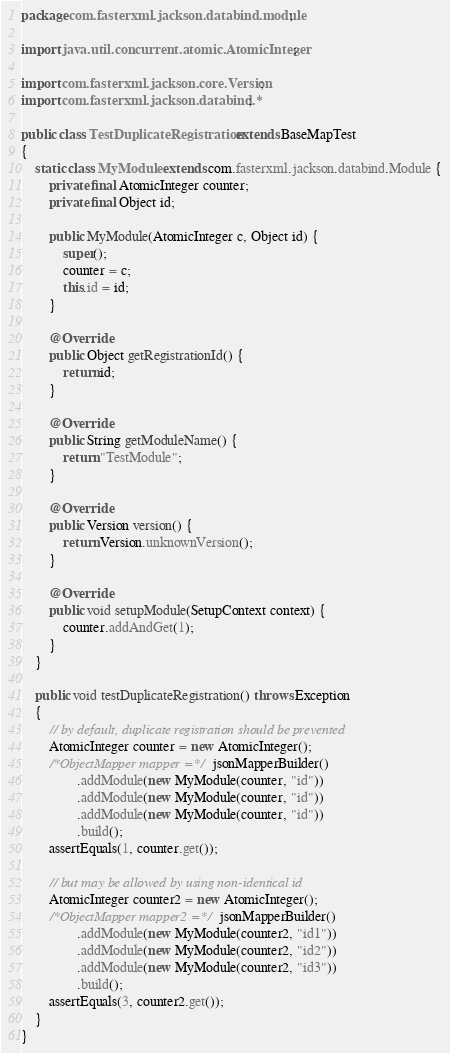Convert code to text. <code><loc_0><loc_0><loc_500><loc_500><_Java_>package com.fasterxml.jackson.databind.module;

import java.util.concurrent.atomic.AtomicInteger;

import com.fasterxml.jackson.core.Version;
import com.fasterxml.jackson.databind.*;

public class TestDuplicateRegistration extends BaseMapTest
{
    static class MyModule extends com.fasterxml.jackson.databind.Module {
        private final AtomicInteger counter;
        private final Object id;

        public MyModule(AtomicInteger c, Object id) {
            super();
            counter = c;
            this.id = id;
        }

        @Override
        public Object getRegistrationId() {
            return id;
        }

        @Override
        public String getModuleName() {
            return "TestModule";
        }

        @Override
        public Version version() {
            return Version.unknownVersion();
        }

        @Override
        public void setupModule(SetupContext context) {
            counter.addAndGet(1);
        }
    }

    public void testDuplicateRegistration() throws Exception
    {
        // by default, duplicate registration should be prevented
        AtomicInteger counter = new AtomicInteger();
        /*ObjectMapper mapper =*/ jsonMapperBuilder()
                .addModule(new MyModule(counter, "id"))
                .addModule(new MyModule(counter, "id"))
                .addModule(new MyModule(counter, "id"))
                .build();
        assertEquals(1, counter.get());

        // but may be allowed by using non-identical id
        AtomicInteger counter2 = new AtomicInteger();
        /*ObjectMapper mapper2 =*/ jsonMapperBuilder()
                .addModule(new MyModule(counter2, "id1"))
                .addModule(new MyModule(counter2, "id2"))
                .addModule(new MyModule(counter2, "id3"))
                .build();
        assertEquals(3, counter2.get());
    }
}
</code> 